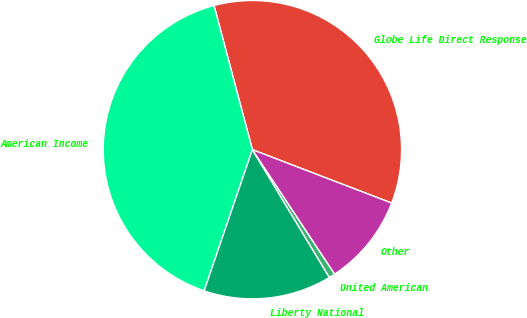<chart> <loc_0><loc_0><loc_500><loc_500><pie_chart><fcel>Globe Life Direct Response<fcel>American Income<fcel>Liberty National<fcel>United American<fcel>Other<nl><fcel>34.97%<fcel>40.62%<fcel>13.87%<fcel>0.67%<fcel>9.87%<nl></chart> 